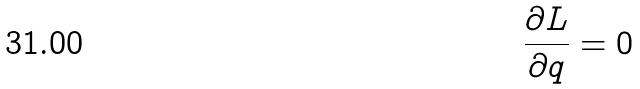Convert formula to latex. <formula><loc_0><loc_0><loc_500><loc_500>\frac { \partial L } { \partial q } = 0</formula> 